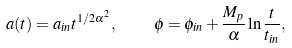Convert formula to latex. <formula><loc_0><loc_0><loc_500><loc_500>a ( t ) = a _ { i n } t ^ { 1 / 2 \alpha ^ { 2 } } , \quad \phi = \phi _ { i n } + \frac { M _ { p } } { \alpha } \ln \frac { t } { t _ { i n } } ,</formula> 